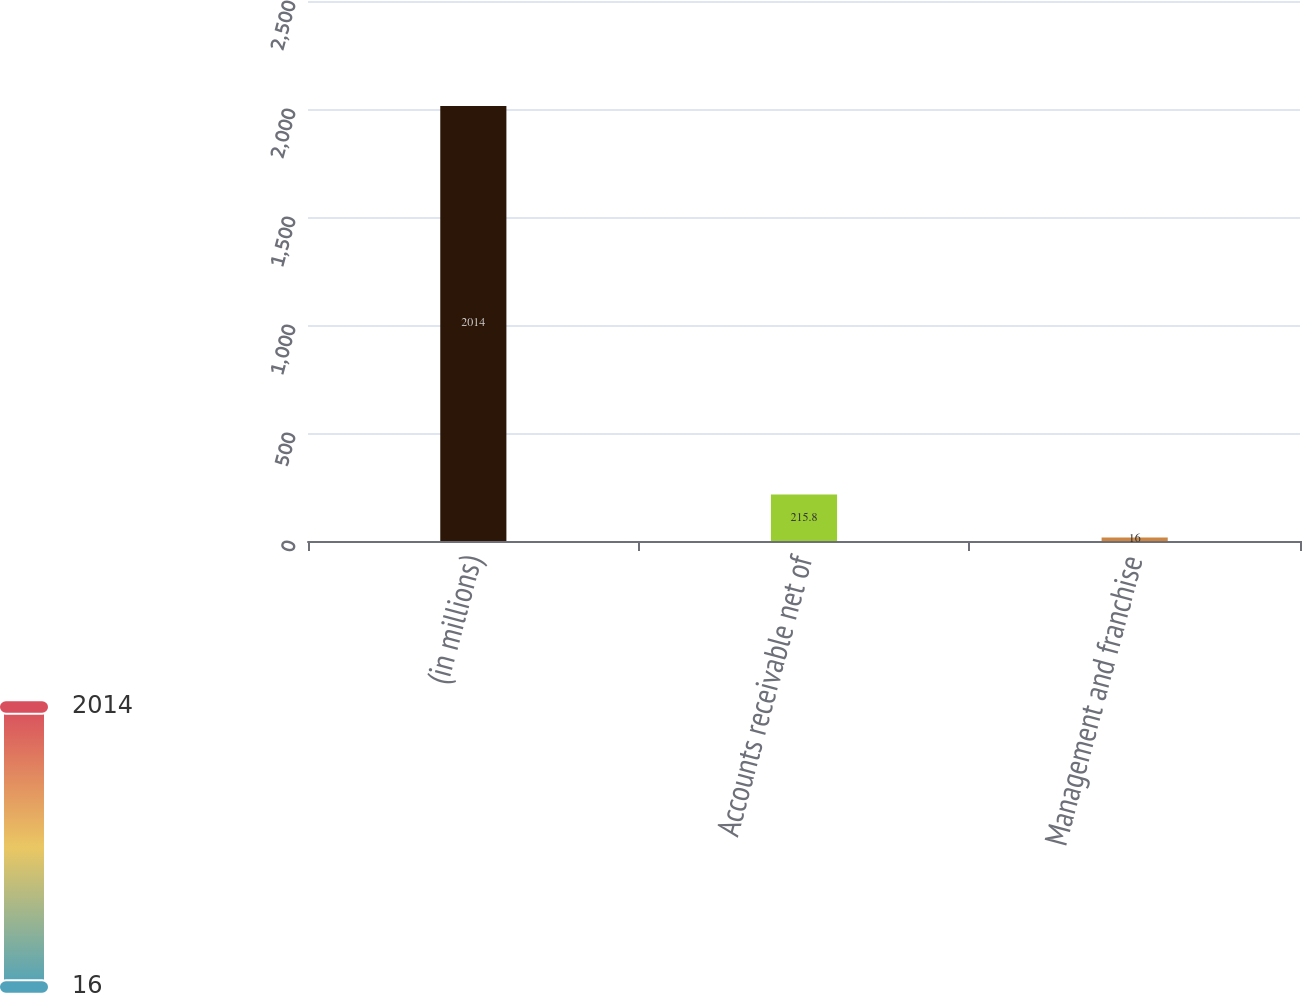Convert chart to OTSL. <chart><loc_0><loc_0><loc_500><loc_500><bar_chart><fcel>(in millions)<fcel>Accounts receivable net of<fcel>Management and franchise<nl><fcel>2014<fcel>215.8<fcel>16<nl></chart> 